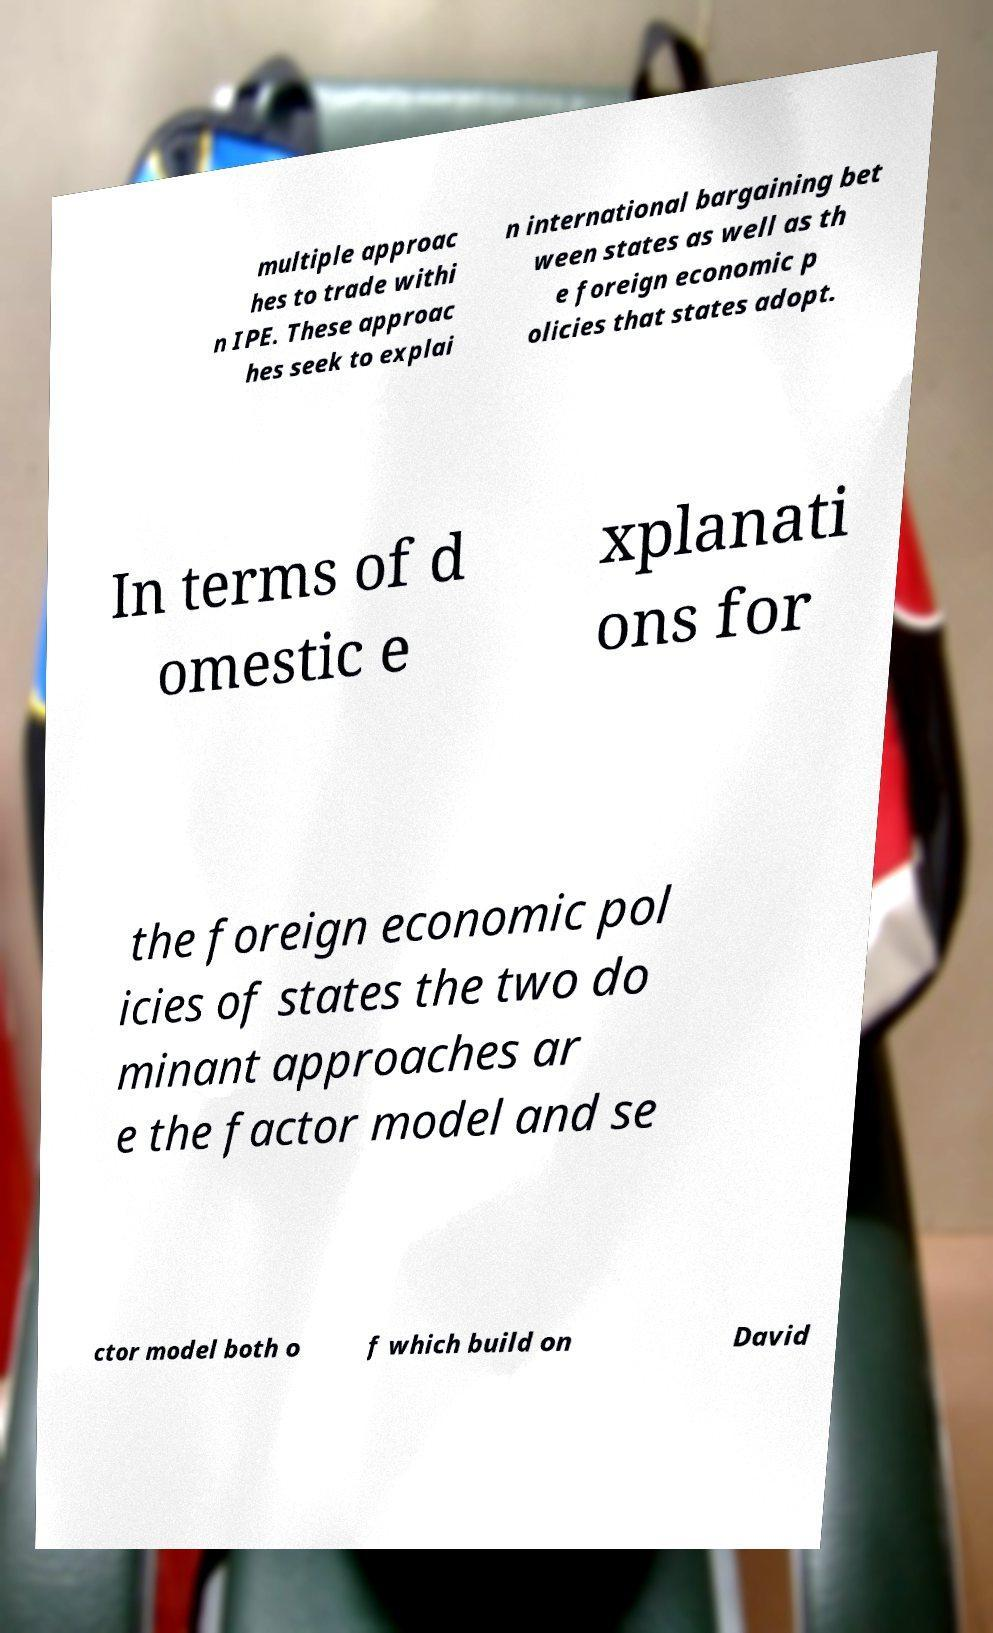Could you assist in decoding the text presented in this image and type it out clearly? multiple approac hes to trade withi n IPE. These approac hes seek to explai n international bargaining bet ween states as well as th e foreign economic p olicies that states adopt. In terms of d omestic e xplanati ons for the foreign economic pol icies of states the two do minant approaches ar e the factor model and se ctor model both o f which build on David 